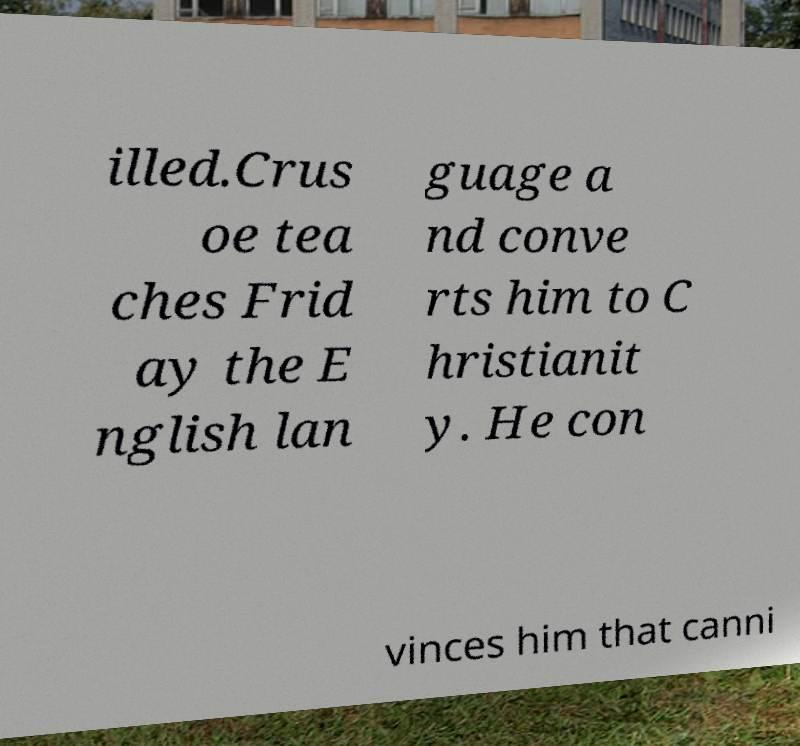Could you extract and type out the text from this image? illed.Crus oe tea ches Frid ay the E nglish lan guage a nd conve rts him to C hristianit y. He con vinces him that canni 